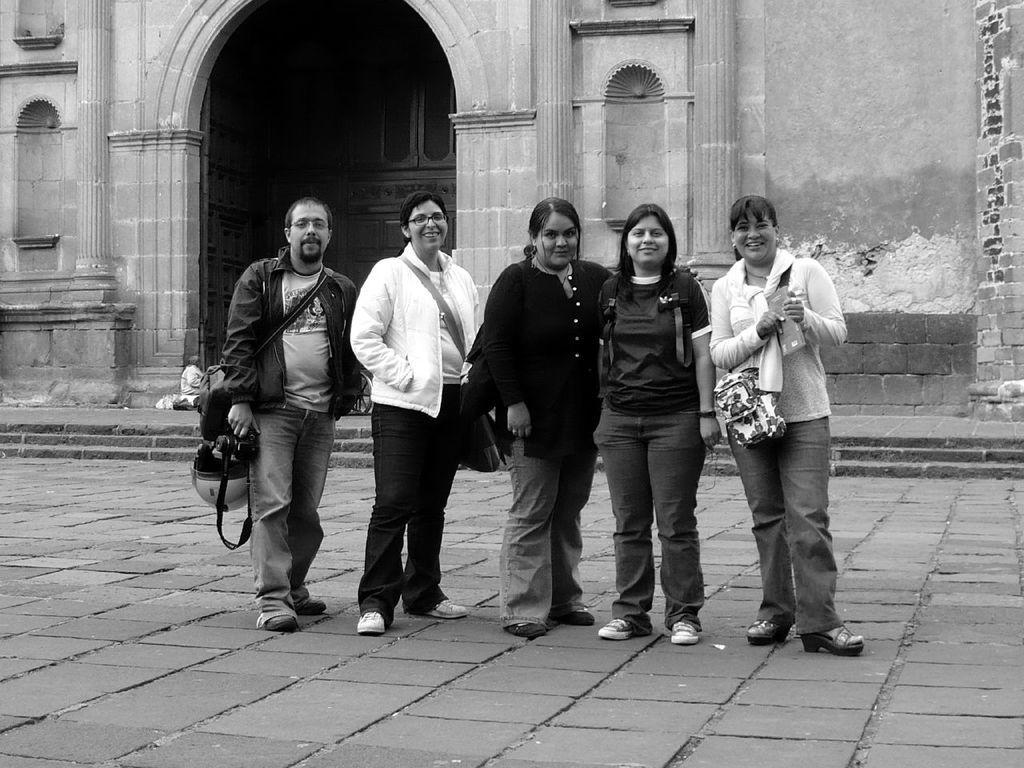Can you describe this image briefly? In this picture there is a woman who is wearing spectacle, white jacket, t-shirt, bag and shoe, beside her there is another woman who is wearing black dress. On the right there is another woman who is wearing jacket, jeans and trouser. She is holding a pamphlet and bag. Beside her there is another woman who is wearing black t-shirt, jeans and sneaker. On the left there is a man who is wearing jacket, t-shirt, trouser, shoe and spectacle. He is holding a bag and helmet. In the background i can see the monument, beside that there are stairs. 